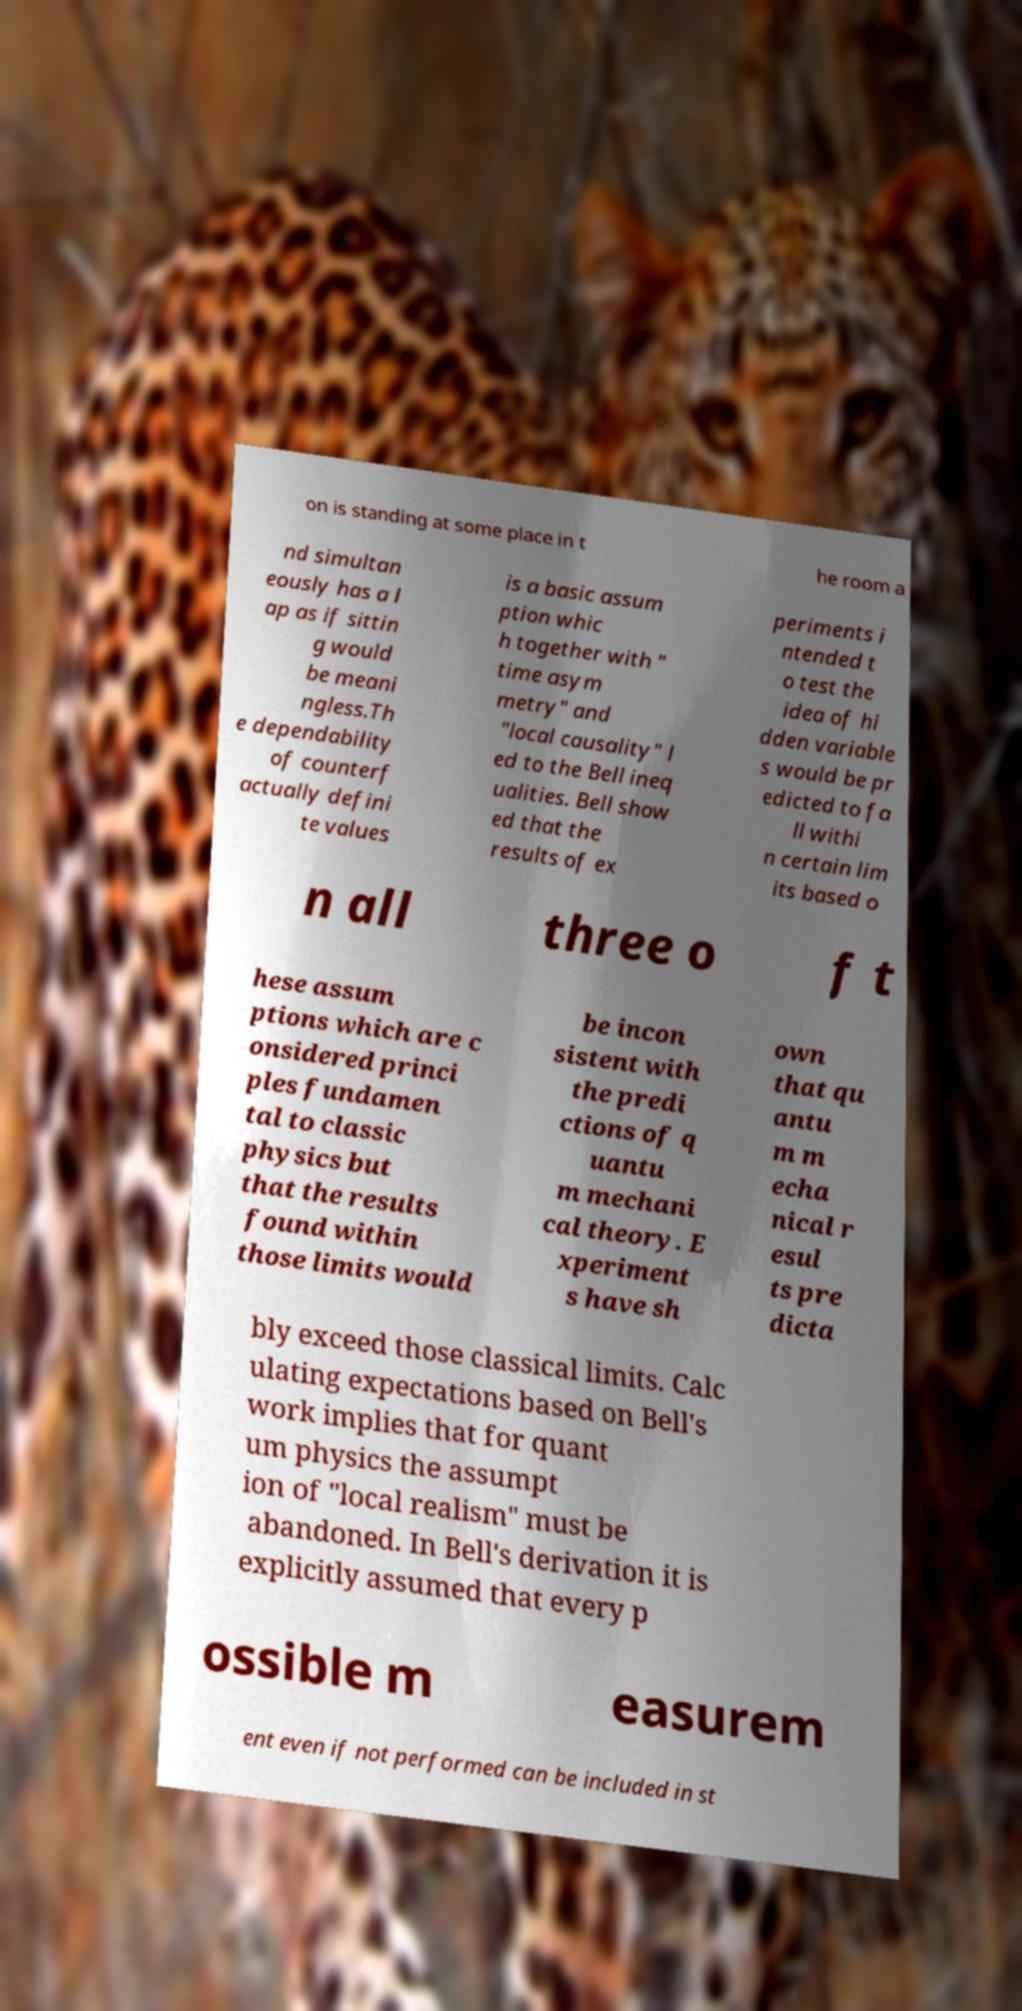Can you accurately transcribe the text from the provided image for me? on is standing at some place in t he room a nd simultan eously has a l ap as if sittin g would be meani ngless.Th e dependability of counterf actually defini te values is a basic assum ption whic h together with " time asym metry" and "local causality" l ed to the Bell ineq ualities. Bell show ed that the results of ex periments i ntended t o test the idea of hi dden variable s would be pr edicted to fa ll withi n certain lim its based o n all three o f t hese assum ptions which are c onsidered princi ples fundamen tal to classic physics but that the results found within those limits would be incon sistent with the predi ctions of q uantu m mechani cal theory. E xperiment s have sh own that qu antu m m echa nical r esul ts pre dicta bly exceed those classical limits. Calc ulating expectations based on Bell's work implies that for quant um physics the assumpt ion of "local realism" must be abandoned. In Bell's derivation it is explicitly assumed that every p ossible m easurem ent even if not performed can be included in st 